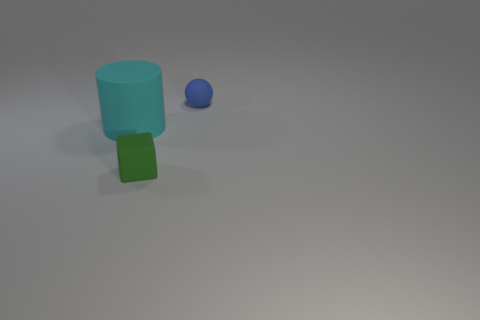Add 2 green rubber blocks. How many objects exist? 5 Subtract all balls. How many objects are left? 2 Subtract 1 cylinders. How many cylinders are left? 0 Subtract all tiny blue things. Subtract all small things. How many objects are left? 0 Add 3 rubber things. How many rubber things are left? 6 Add 1 large rubber balls. How many large rubber balls exist? 1 Subtract 0 gray blocks. How many objects are left? 3 Subtract all purple cylinders. Subtract all gray blocks. How many cylinders are left? 1 Subtract all purple cylinders. How many brown cubes are left? 0 